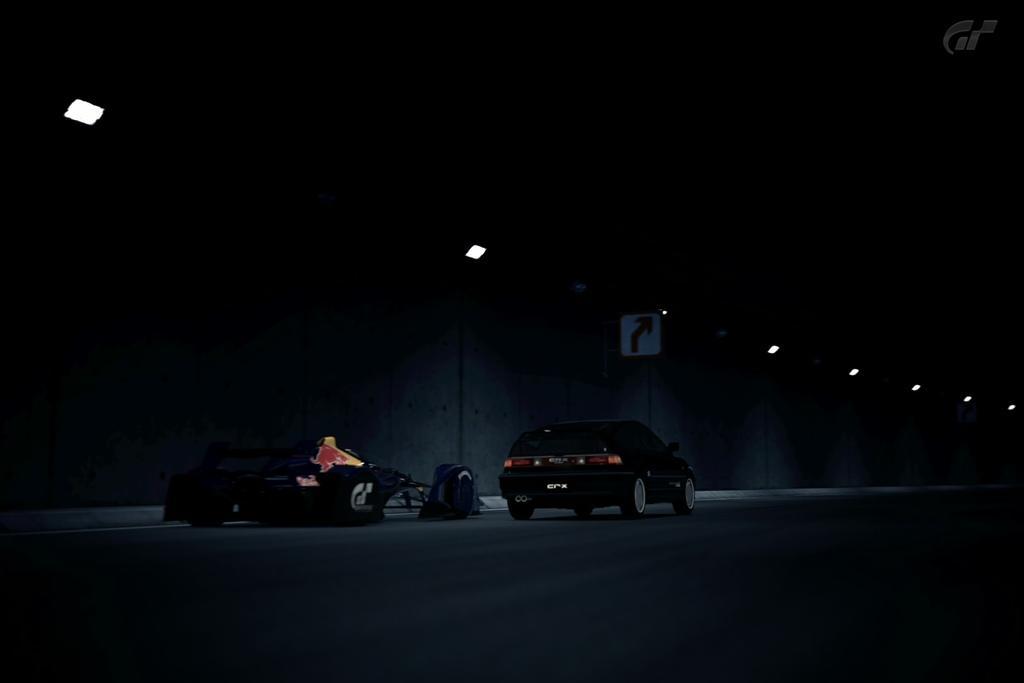Could you give a brief overview of what you see in this image? In this image I can see few vehicles, a direction board and number of lights. I can also see this image is in dark. 